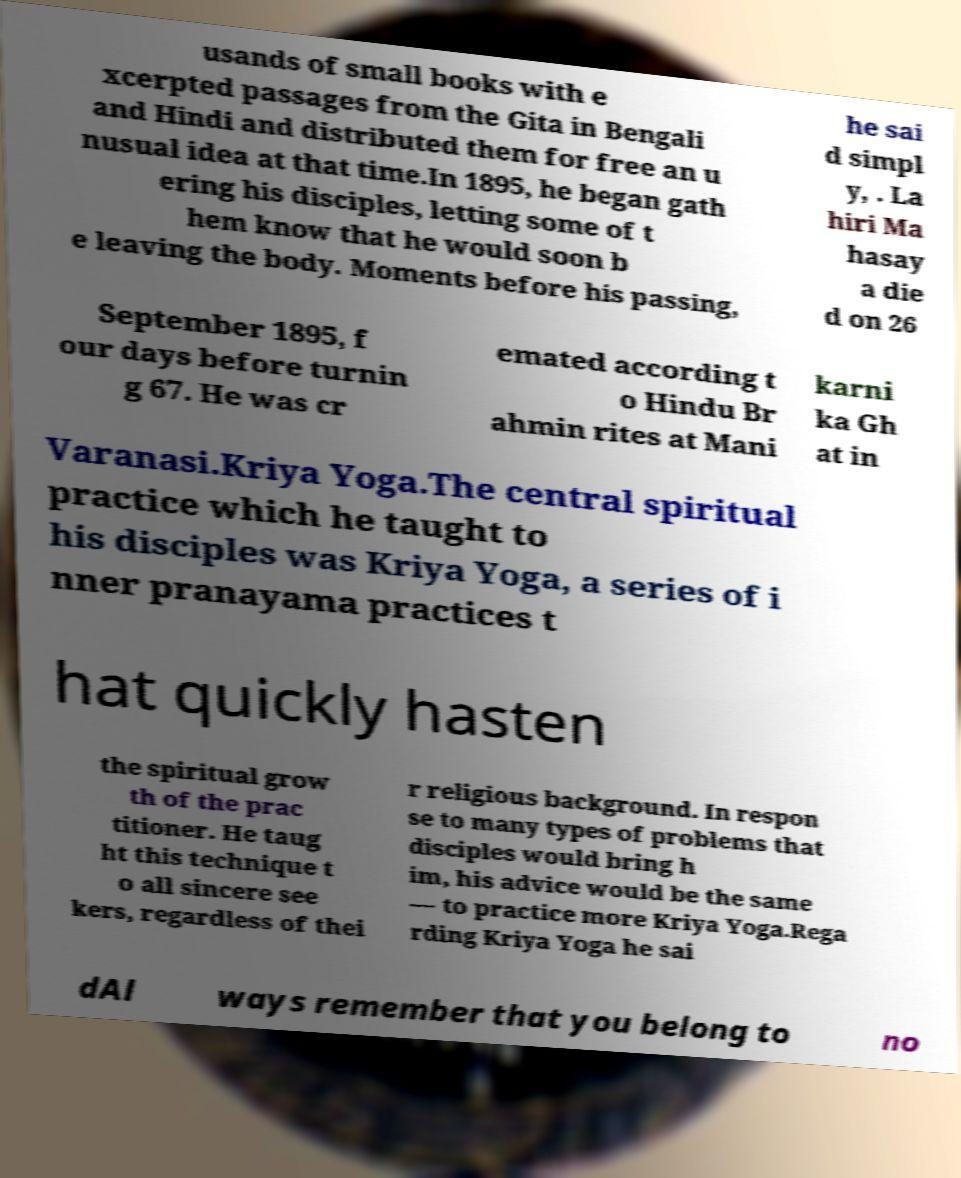For documentation purposes, I need the text within this image transcribed. Could you provide that? usands of small books with e xcerpted passages from the Gita in Bengali and Hindi and distributed them for free an u nusual idea at that time.In 1895, he began gath ering his disciples, letting some of t hem know that he would soon b e leaving the body. Moments before his passing, he sai d simpl y, . La hiri Ma hasay a die d on 26 September 1895, f our days before turnin g 67. He was cr emated according t o Hindu Br ahmin rites at Mani karni ka Gh at in Varanasi.Kriya Yoga.The central spiritual practice which he taught to his disciples was Kriya Yoga, a series of i nner pranayama practices t hat quickly hasten the spiritual grow th of the prac titioner. He taug ht this technique t o all sincere see kers, regardless of thei r religious background. In respon se to many types of problems that disciples would bring h im, his advice would be the same — to practice more Kriya Yoga.Rega rding Kriya Yoga he sai dAl ways remember that you belong to no 